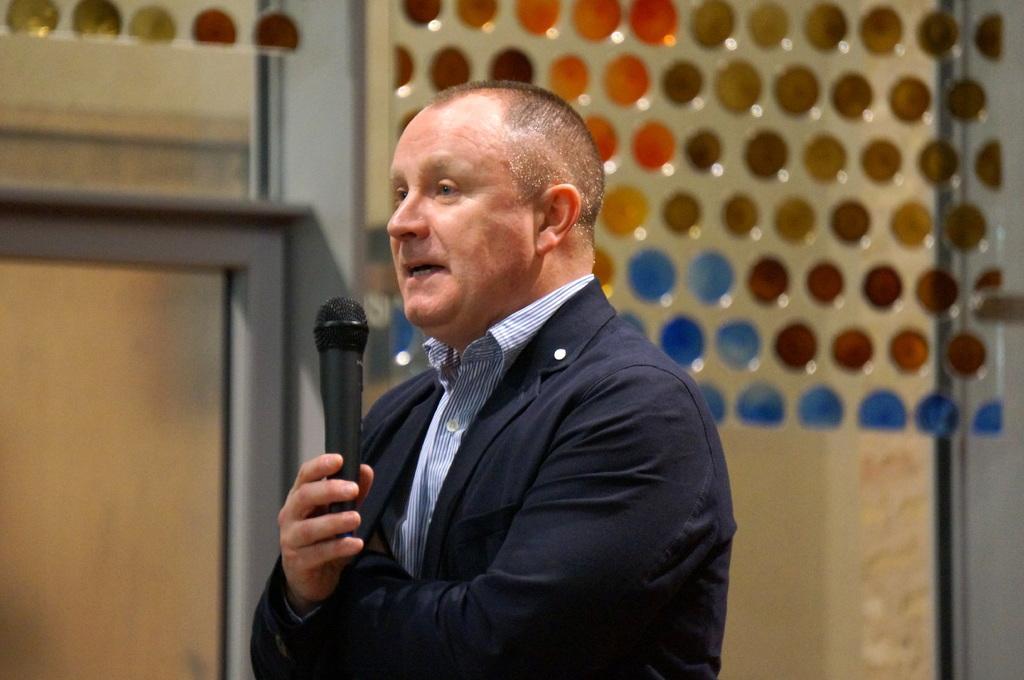In one or two sentences, can you explain what this image depicts? There is a person standing in the center and he is speaking on a microphone. 